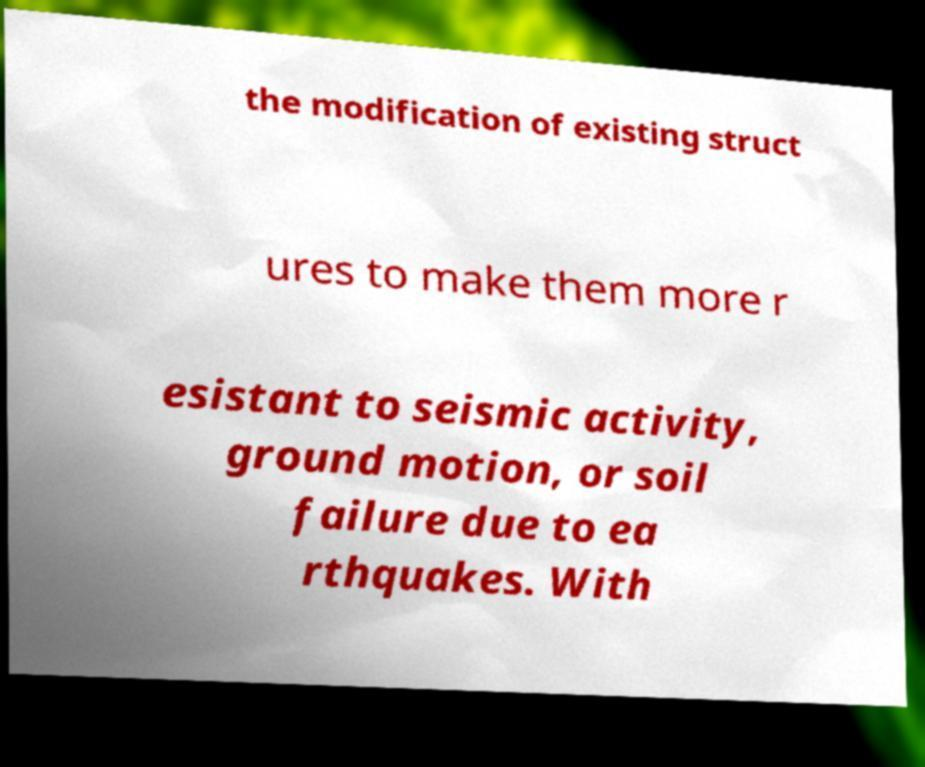Can you accurately transcribe the text from the provided image for me? the modification of existing struct ures to make them more r esistant to seismic activity, ground motion, or soil failure due to ea rthquakes. With 